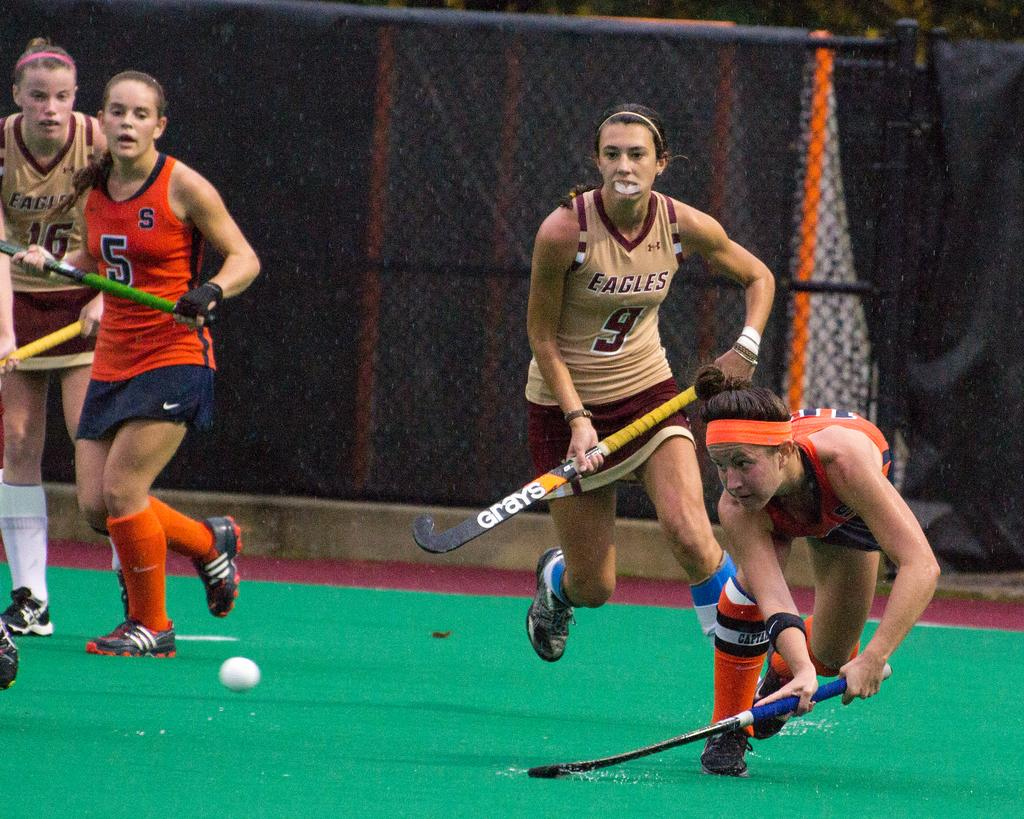<image>
Render a clear and concise summary of the photo. A woman playing for the Eagles is running towards the ball. 